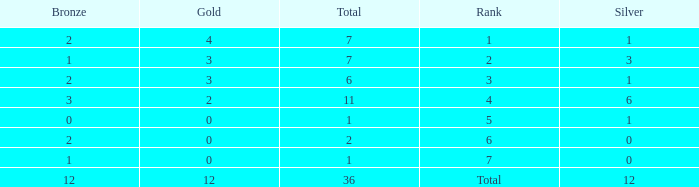What is the number of bronze medals when there are fewer than 0 silver medals? None. 